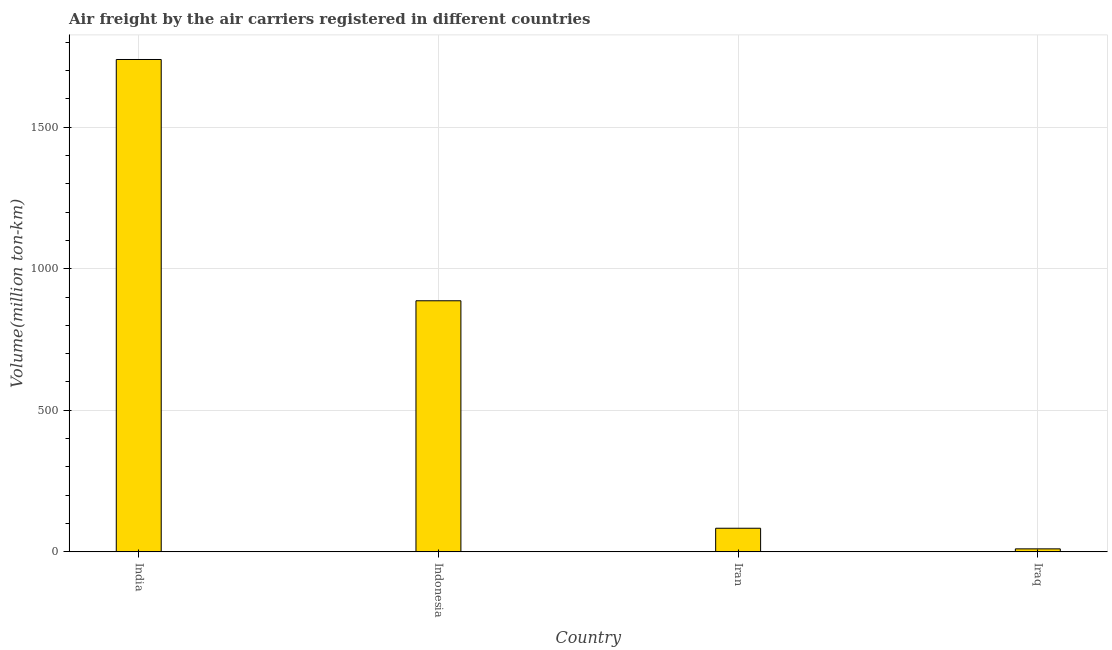Does the graph contain grids?
Provide a succinct answer. Yes. What is the title of the graph?
Give a very brief answer. Air freight by the air carriers registered in different countries. What is the label or title of the X-axis?
Your response must be concise. Country. What is the label or title of the Y-axis?
Your answer should be compact. Volume(million ton-km). What is the air freight in India?
Your response must be concise. 1738.98. Across all countries, what is the maximum air freight?
Keep it short and to the point. 1738.98. Across all countries, what is the minimum air freight?
Offer a terse response. 10.62. In which country was the air freight minimum?
Make the answer very short. Iraq. What is the sum of the air freight?
Your response must be concise. 2719.9. What is the difference between the air freight in India and Iran?
Make the answer very short. 1655.53. What is the average air freight per country?
Make the answer very short. 679.98. What is the median air freight?
Keep it short and to the point. 485.15. What is the ratio of the air freight in Indonesia to that in Iran?
Give a very brief answer. 10.63. Is the difference between the air freight in Indonesia and Iran greater than the difference between any two countries?
Make the answer very short. No. What is the difference between the highest and the second highest air freight?
Ensure brevity in your answer.  852.13. What is the difference between the highest and the lowest air freight?
Make the answer very short. 1728.36. In how many countries, is the air freight greater than the average air freight taken over all countries?
Offer a very short reply. 2. What is the Volume(million ton-km) in India?
Your answer should be very brief. 1738.98. What is the Volume(million ton-km) in Indonesia?
Keep it short and to the point. 886.85. What is the Volume(million ton-km) of Iran?
Provide a short and direct response. 83.45. What is the Volume(million ton-km) in Iraq?
Your response must be concise. 10.62. What is the difference between the Volume(million ton-km) in India and Indonesia?
Your answer should be compact. 852.13. What is the difference between the Volume(million ton-km) in India and Iran?
Your answer should be very brief. 1655.53. What is the difference between the Volume(million ton-km) in India and Iraq?
Your answer should be very brief. 1728.36. What is the difference between the Volume(million ton-km) in Indonesia and Iran?
Make the answer very short. 803.4. What is the difference between the Volume(million ton-km) in Indonesia and Iraq?
Give a very brief answer. 876.23. What is the difference between the Volume(million ton-km) in Iran and Iraq?
Your answer should be compact. 72.83. What is the ratio of the Volume(million ton-km) in India to that in Indonesia?
Your answer should be compact. 1.96. What is the ratio of the Volume(million ton-km) in India to that in Iran?
Your answer should be compact. 20.84. What is the ratio of the Volume(million ton-km) in India to that in Iraq?
Offer a terse response. 163.76. What is the ratio of the Volume(million ton-km) in Indonesia to that in Iran?
Provide a succinct answer. 10.63. What is the ratio of the Volume(million ton-km) in Indonesia to that in Iraq?
Offer a very short reply. 83.52. What is the ratio of the Volume(million ton-km) in Iran to that in Iraq?
Keep it short and to the point. 7.86. 